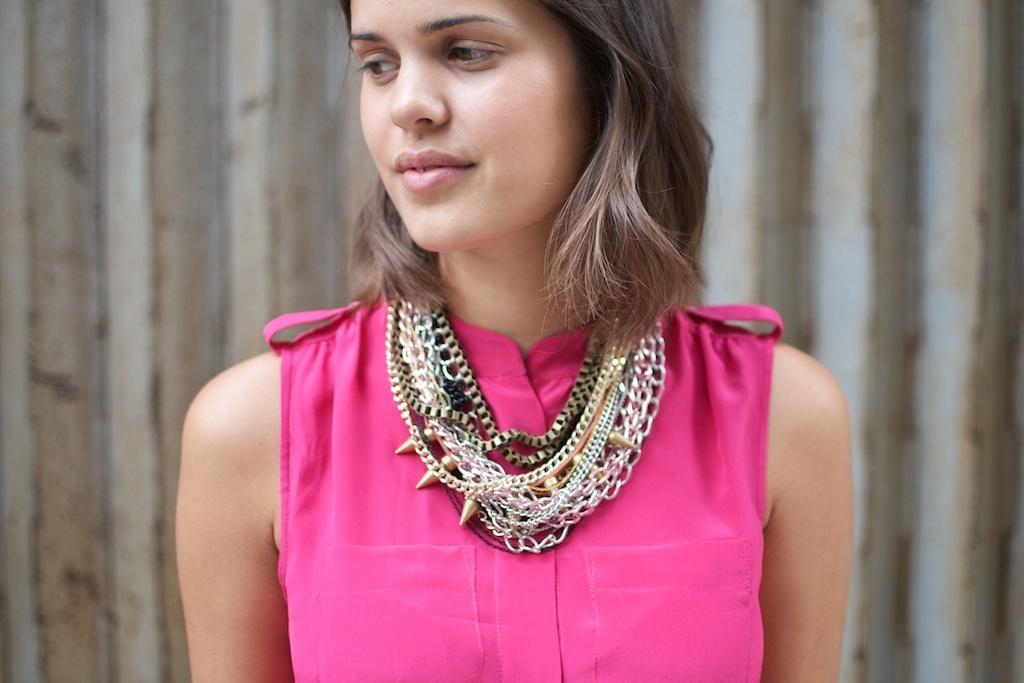Describe this image in one or two sentences. In this image we can see a lady wearing pink color dress, and some necklaces. 